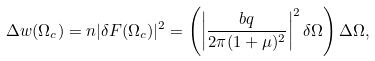<formula> <loc_0><loc_0><loc_500><loc_500>\Delta w ( \Omega _ { c } ) = n | \delta F ( \Omega _ { c } ) | ^ { 2 } = \left ( \left | \frac { b q } { 2 \pi ( 1 + \mu ) ^ { 2 } } \right | ^ { 2 } \delta \Omega \right ) \Delta \Omega ,</formula> 